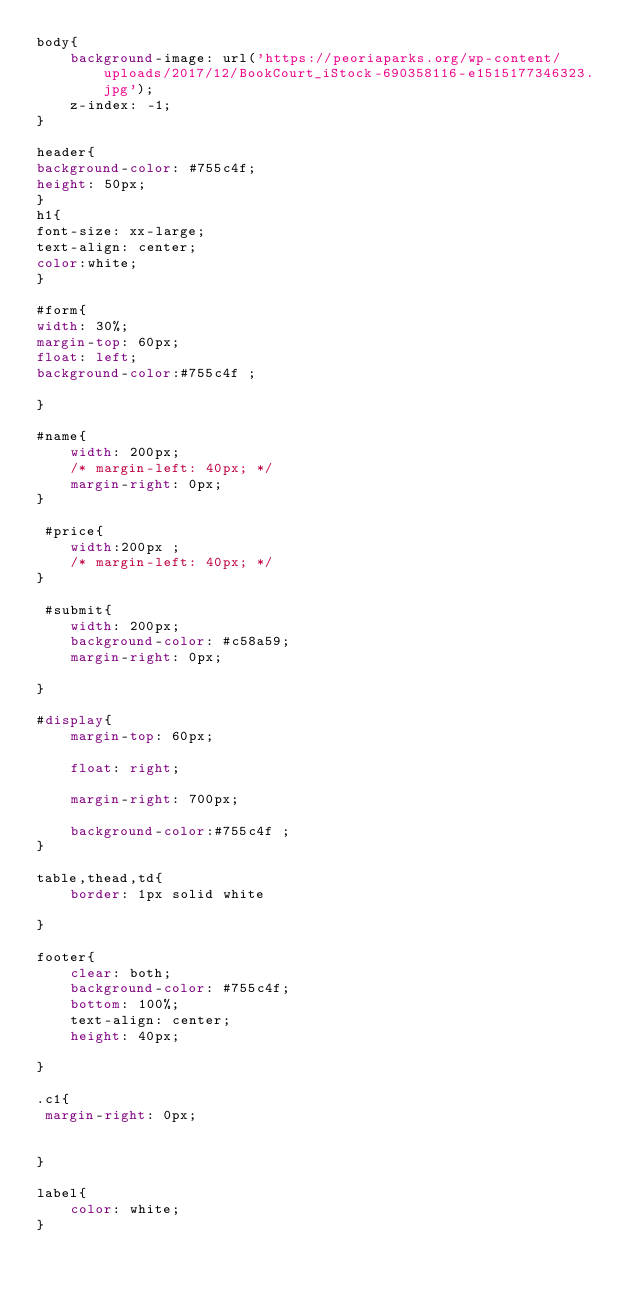Convert code to text. <code><loc_0><loc_0><loc_500><loc_500><_CSS_>body{
    background-image: url('https://peoriaparks.org/wp-content/uploads/2017/12/BookCourt_iStock-690358116-e1515177346323.jpg');
    z-index: -1;
}

header{
background-color: #755c4f;
height: 50px;
}
h1{
font-size: xx-large;
text-align: center;
color:white;
}

#form{
width: 30%;
margin-top: 60px;
float: left;
background-color:#755c4f ;

}

#name{
    width: 200px;
    /* margin-left: 40px; */
    margin-right: 0px;
} 

 #price{
    width:200px ;
    /* margin-left: 40px; */
} 

 #submit{
    width: 200px;
    background-color: #c58a59;
    margin-right: 0px;

}

#display{
    margin-top: 60px;

    float: right;

    margin-right: 700px;

    background-color:#755c4f ;
}

table,thead,td{
    border: 1px solid white

}

footer{
    clear: both;
    background-color: #755c4f;
    bottom: 100%;
    text-align: center;
    height: 40px;
    
}

.c1{
 margin-right: 0px;


}

label{
    color: white;
}</code> 